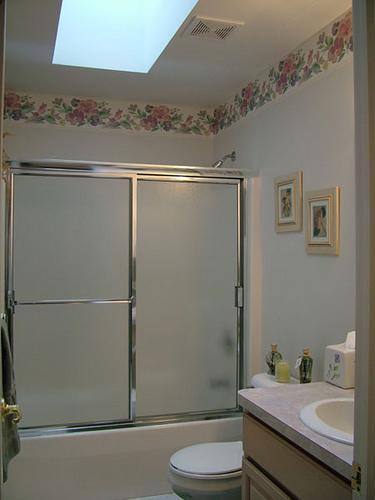How many sinks are there?
Give a very brief answer. 1. How many windows are in the bathroom?
Give a very brief answer. 0. How many sinks do you see?
Give a very brief answer. 1. 